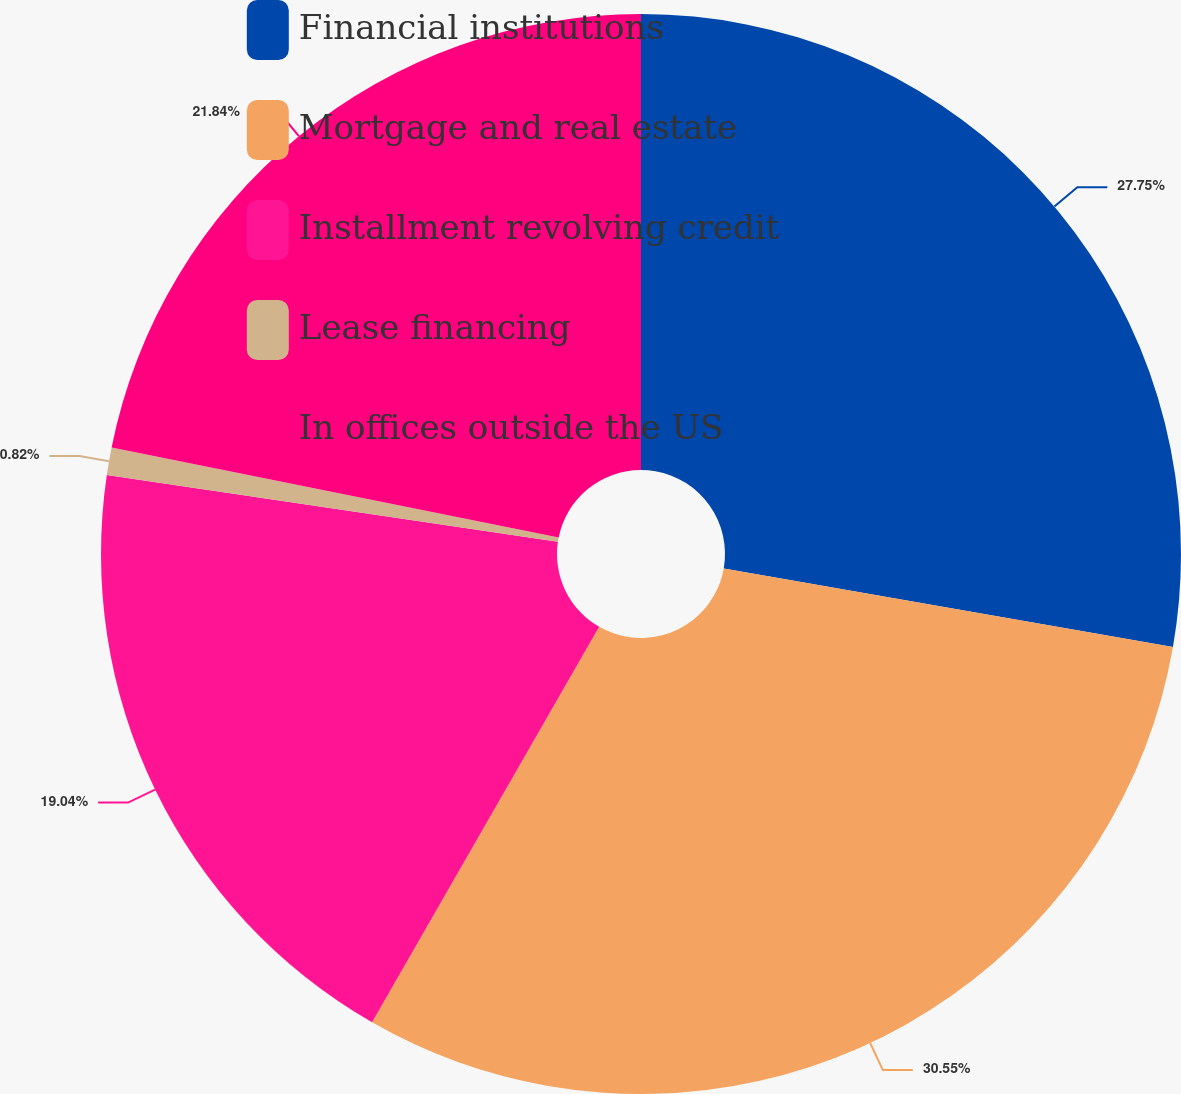Convert chart. <chart><loc_0><loc_0><loc_500><loc_500><pie_chart><fcel>Financial institutions<fcel>Mortgage and real estate<fcel>Installment revolving credit<fcel>Lease financing<fcel>In offices outside the US<nl><fcel>27.75%<fcel>30.54%<fcel>19.04%<fcel>0.82%<fcel>21.84%<nl></chart> 